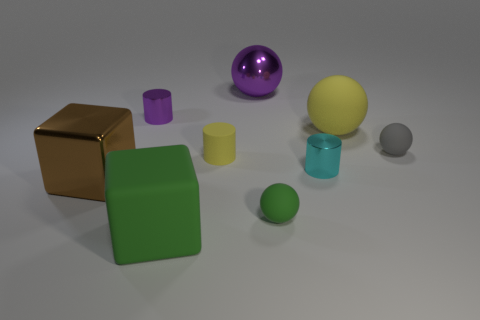Subtract 1 spheres. How many spheres are left? 3 Add 1 brown metallic cylinders. How many objects exist? 10 Subtract all cylinders. How many objects are left? 6 Subtract all matte things. Subtract all small purple shiny things. How many objects are left? 3 Add 3 green rubber things. How many green rubber things are left? 5 Add 3 big gray rubber things. How many big gray rubber things exist? 3 Subtract 1 green blocks. How many objects are left? 8 